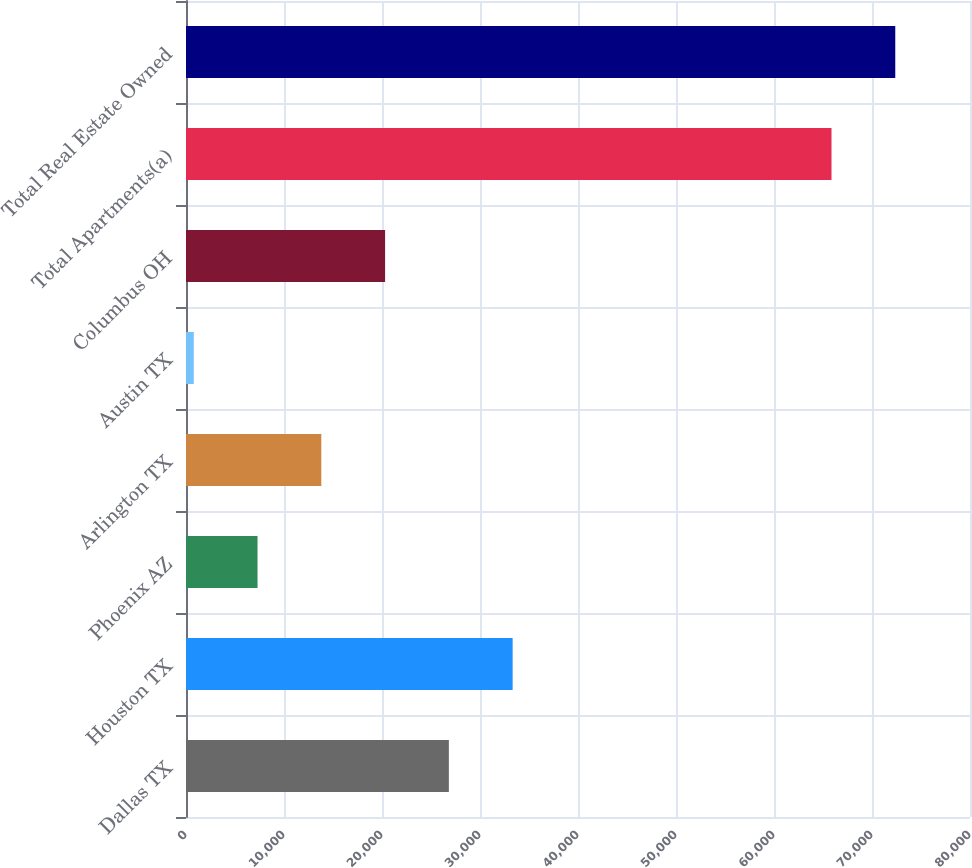<chart> <loc_0><loc_0><loc_500><loc_500><bar_chart><fcel>Dallas TX<fcel>Houston TX<fcel>Phoenix AZ<fcel>Arlington TX<fcel>Austin TX<fcel>Columbus OH<fcel>Total Apartments(a)<fcel>Total Real Estate Owned<nl><fcel>26822<fcel>33329.5<fcel>7299.5<fcel>13807<fcel>792<fcel>20314.5<fcel>65867<fcel>72374.5<nl></chart> 